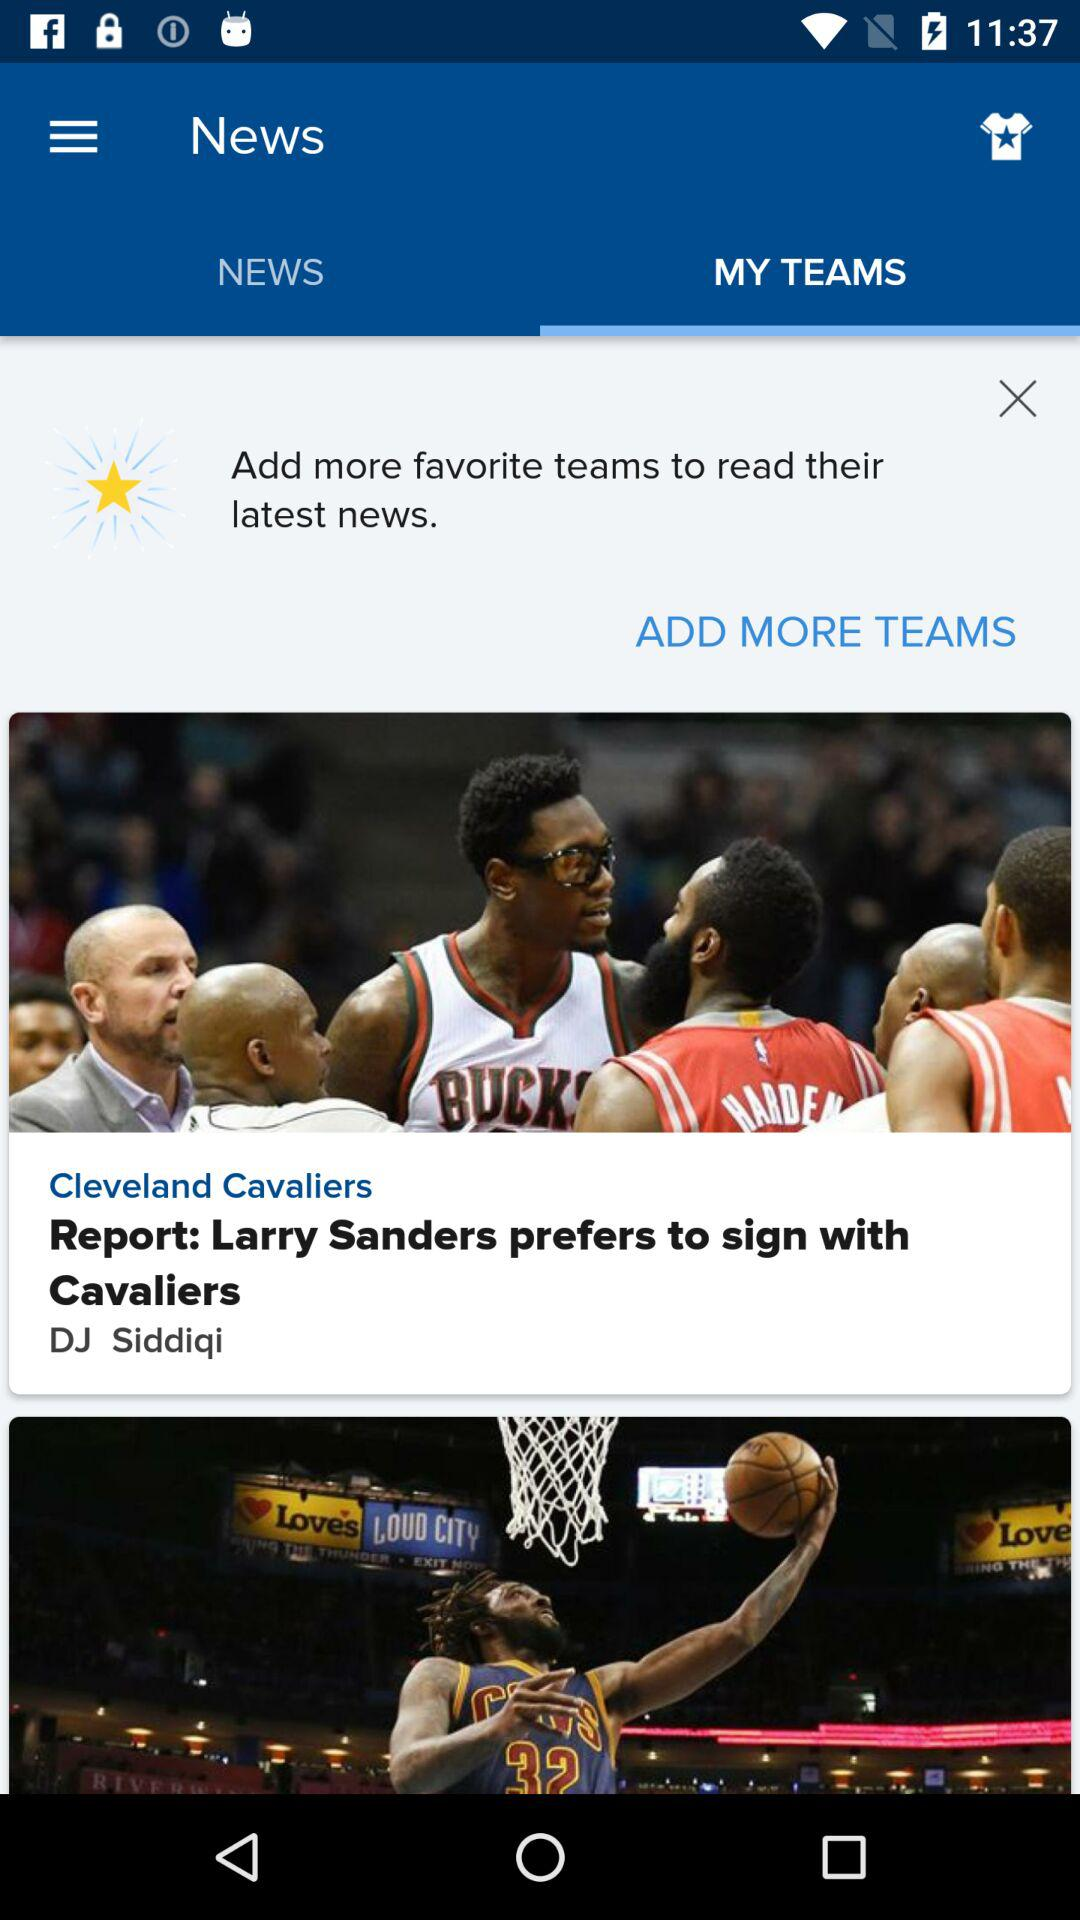What tab is selected? The selected tab is "MY TEAMS". 